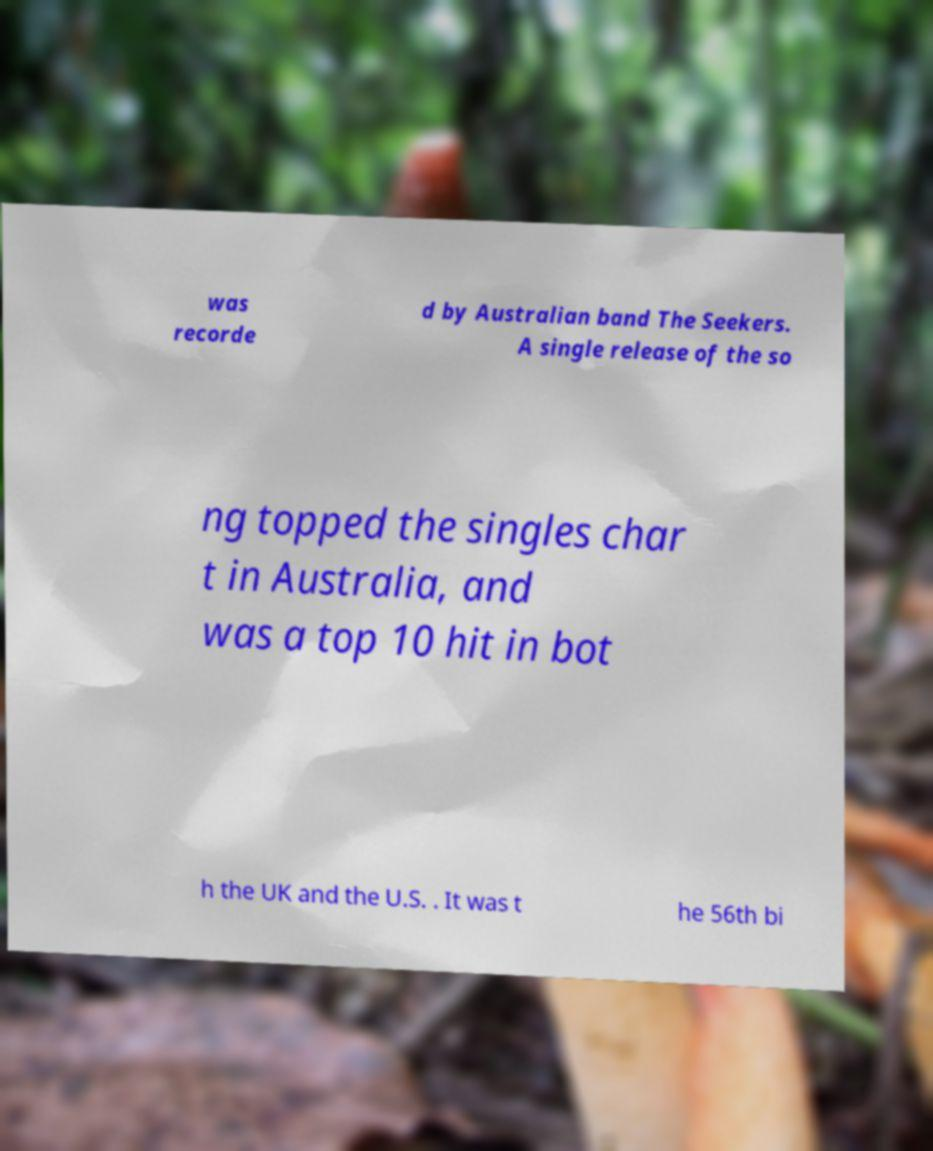What messages or text are displayed in this image? I need them in a readable, typed format. was recorde d by Australian band The Seekers. A single release of the so ng topped the singles char t in Australia, and was a top 10 hit in bot h the UK and the U.S. . It was t he 56th bi 